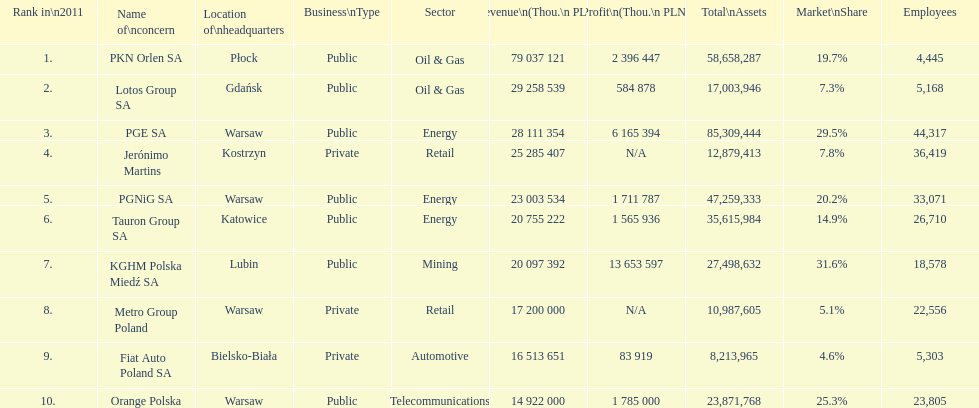What is the number of employees who work for pgnig sa? 33,071. 